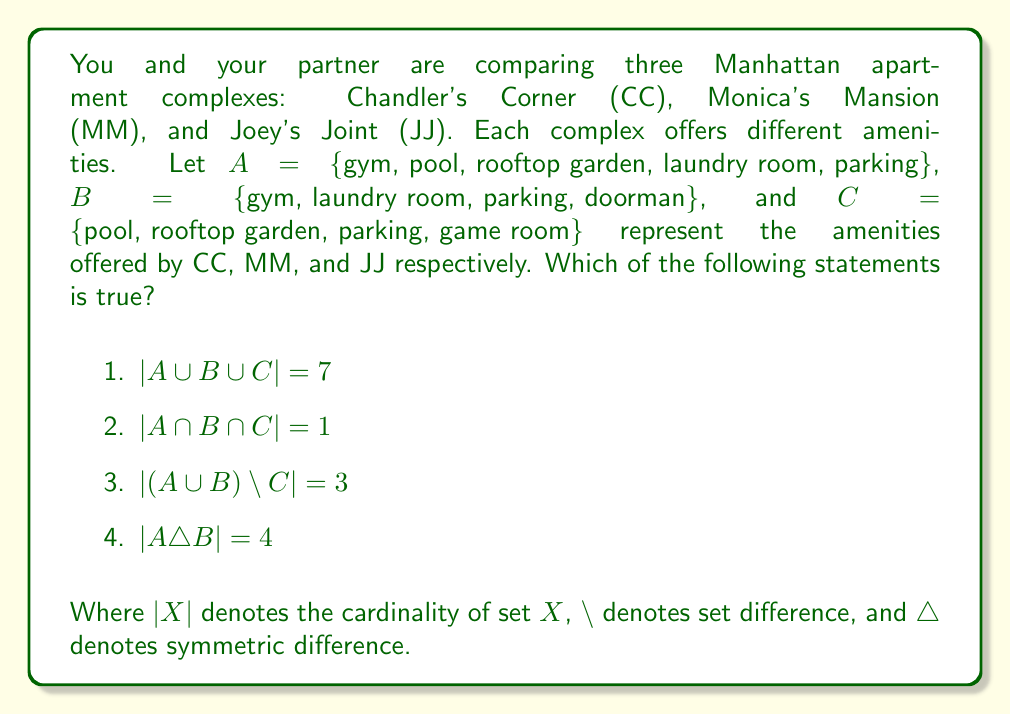Can you answer this question? Let's analyze each statement using set theory:

1. $|A \cup B \cup C|$:
   First, list all unique elements in A, B, and C:
   A ∪ B ∪ C = {gym, pool, rooftop garden, laundry room, parking, doorman, game room}
   Count the elements: $|A \cup B \cup C| = 7$
   This statement is true.

2. $|A \cap B \cap C|$:
   Find elements common to all three sets:
   A ∩ B ∩ C = {parking}
   Count the elements: $|A \cap B \cap C| = 1$
   This statement is true.

3. $|(A \cup B) \setminus C|$:
   First, find A ∪ B:
   A ∪ B = {gym, pool, rooftop garden, laundry room, parking, doorman}
   Then, remove elements in C:
   (A ∪ B) \ C = {gym, laundry room, doorman}
   Count the elements: $|(A \cup B) \setminus C| = 3$
   This statement is true.

4. $|A \triangle B|$:
   Symmetric difference is defined as: $A \triangle B = (A \setminus B) \cup (B \setminus A)$
   A \ B = {pool, rooftop garden}
   B \ A = {doorman}
   A △ B = {pool, rooftop garden, doorman}
   Count the elements: $|A \triangle B| = 3$
   This statement is false.
Answer: The correct answer is statement 3: $|(A \cup B) \setminus C| = 3$ 